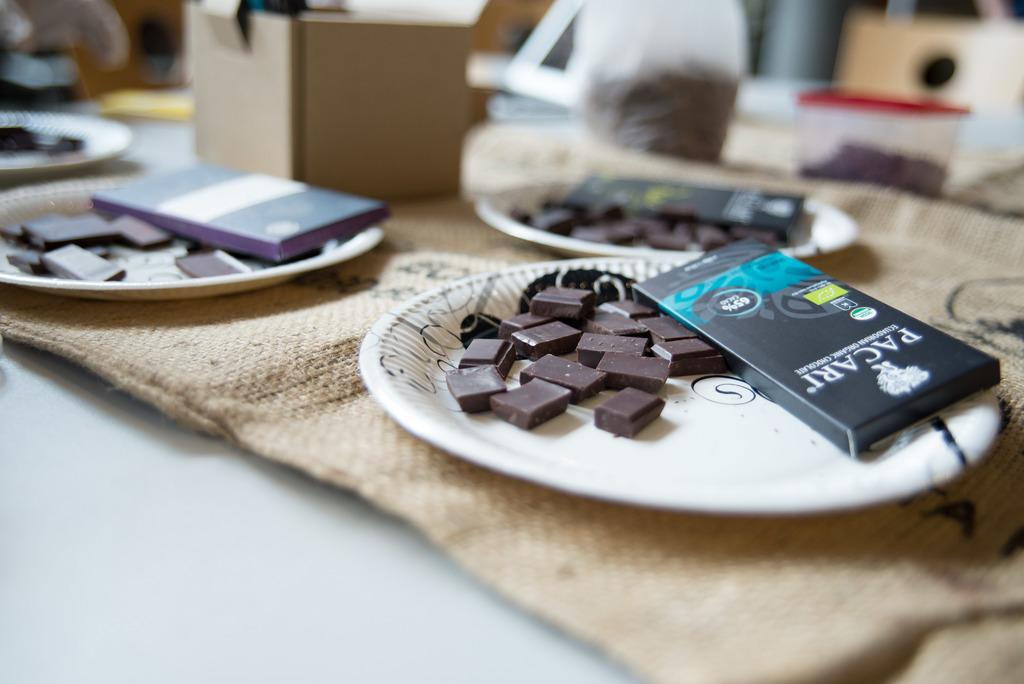What type of food is visible in the image? There are chocolates in the image. What objects are also present in the image? There are boxes in the image. How are the chocolates and boxes arranged? The chocolates and boxes are on plates. What else can be seen beside the plates in the image? There are additional boxes and other items beside the plates. Is there any quicksand visible in the image? No, there is no quicksand present in the image. Can you see any clams in the image? No, there are no clams present in the image. 